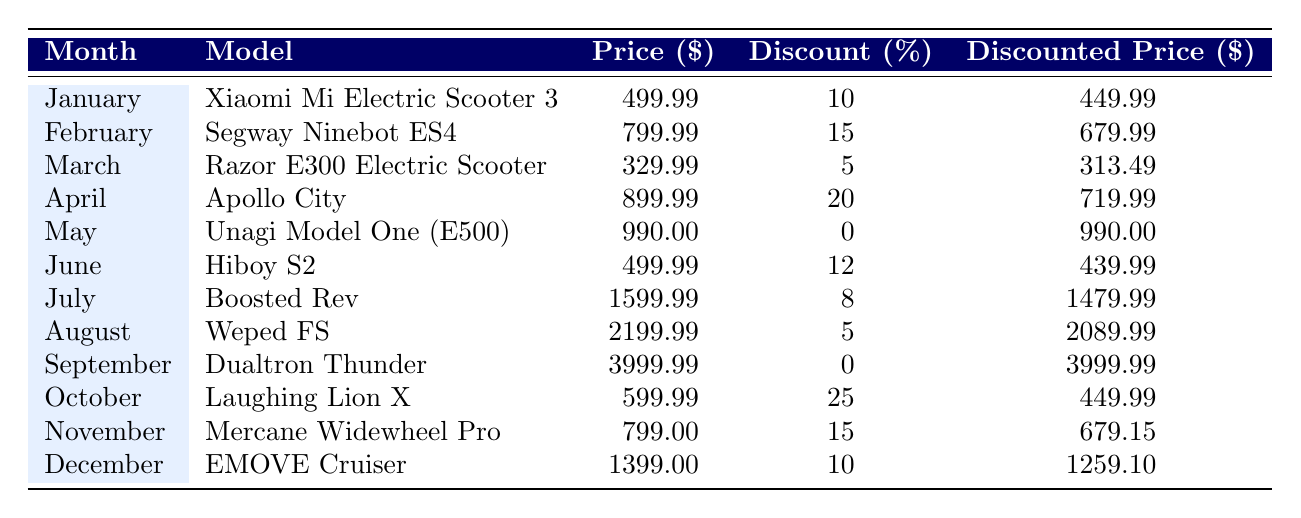What was the highest discount percentage offered in any month? The highest discount percentage can be found by scanning the "Discount (%)" column. The maximum value is 25%, offered in October for the Laughing Lion X model.
Answer: 25 Which electric scooter had the lowest discounted price in 2023? To find the lowest discounted price, we look at the "Discounted Price ($)" column and identify the minimum value. The cheapest is the Razor E300 Electric Scooter at $313.49.
Answer: Razor E300 Electric Scooter What is the average price of electric scooters in June and July combined? We need to consider the prices from June (Hiboy S2) and July (Boosted Rev). The prices are 499.99 and 1599.99 respectively. The average is (499.99 + 1599.99) / 2 = 1099.99.
Answer: 1099.99 Did the Segway Ninebot ES4 model have a discount higher than 10%? Checking the discount percentage for the Segway Ninebot ES4, which is 15%. Since 15% > 10%, the answer is yes.
Answer: Yes What is the price difference between the most expensive scooter and the least expensive scooter in the table? The most expensive scooter is the Dualtron Thunder at 3999.99, while the least expensive is the Razor E300 at 329.99. The price difference is 3999.99 - 329.99 = 3670.00.
Answer: 3670.00 